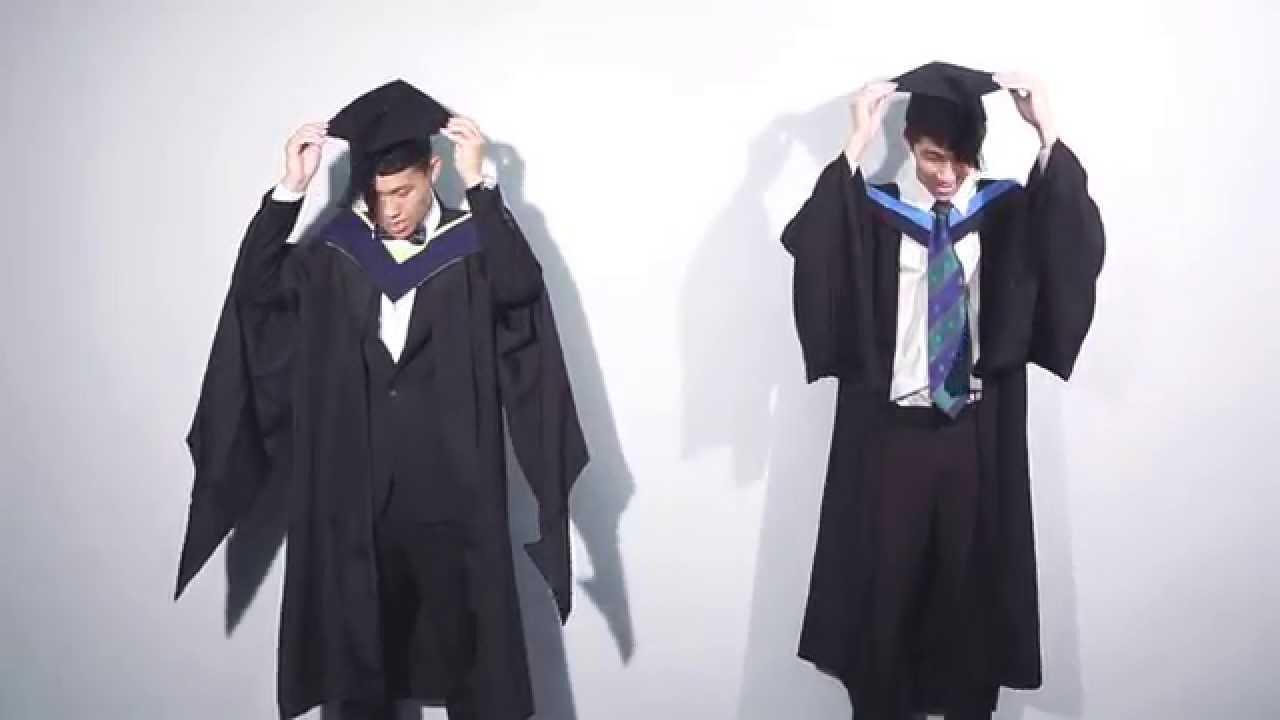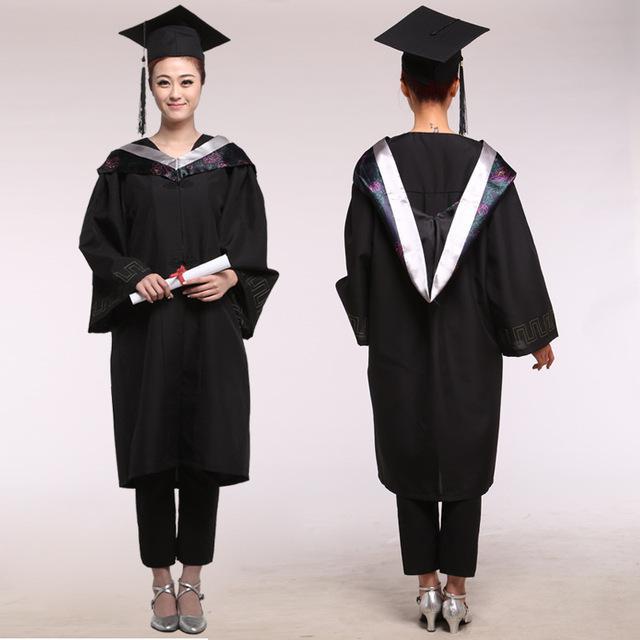The first image is the image on the left, the second image is the image on the right. For the images shown, is this caption "In one image, a graduation gown model is wearing silver high heeled shoes." true? Answer yes or no. Yes. The first image is the image on the left, the second image is the image on the right. Evaluate the accuracy of this statement regarding the images: "One out of four graduates has her back turned towards the camera.". Is it true? Answer yes or no. Yes. 